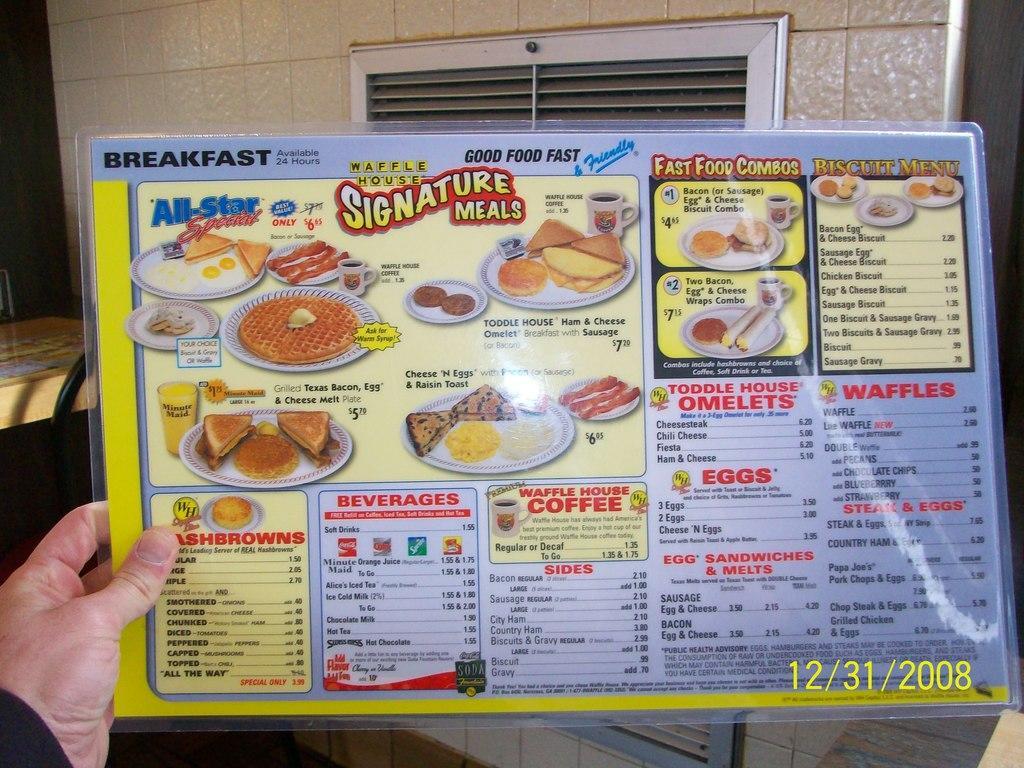Please provide a concise description of this image. In this picture there is a food menu in the center of the image in a hand, it seems to be there is a window in the background area of the image, it seems to be there is a table and a chair on the left side of the image. 